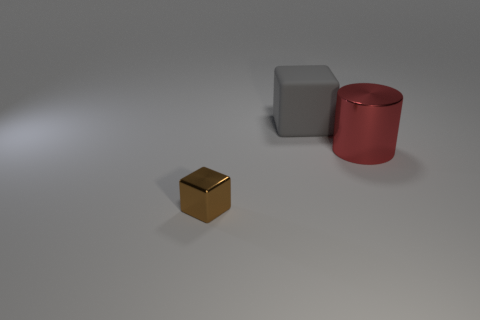Add 3 metal blocks. How many objects exist? 6 Subtract all blocks. How many objects are left? 1 Add 2 big green blocks. How many big green blocks exist? 2 Subtract 0 blue cylinders. How many objects are left? 3 Subtract all tiny brown metal cubes. Subtract all metallic things. How many objects are left? 0 Add 2 gray rubber things. How many gray rubber things are left? 3 